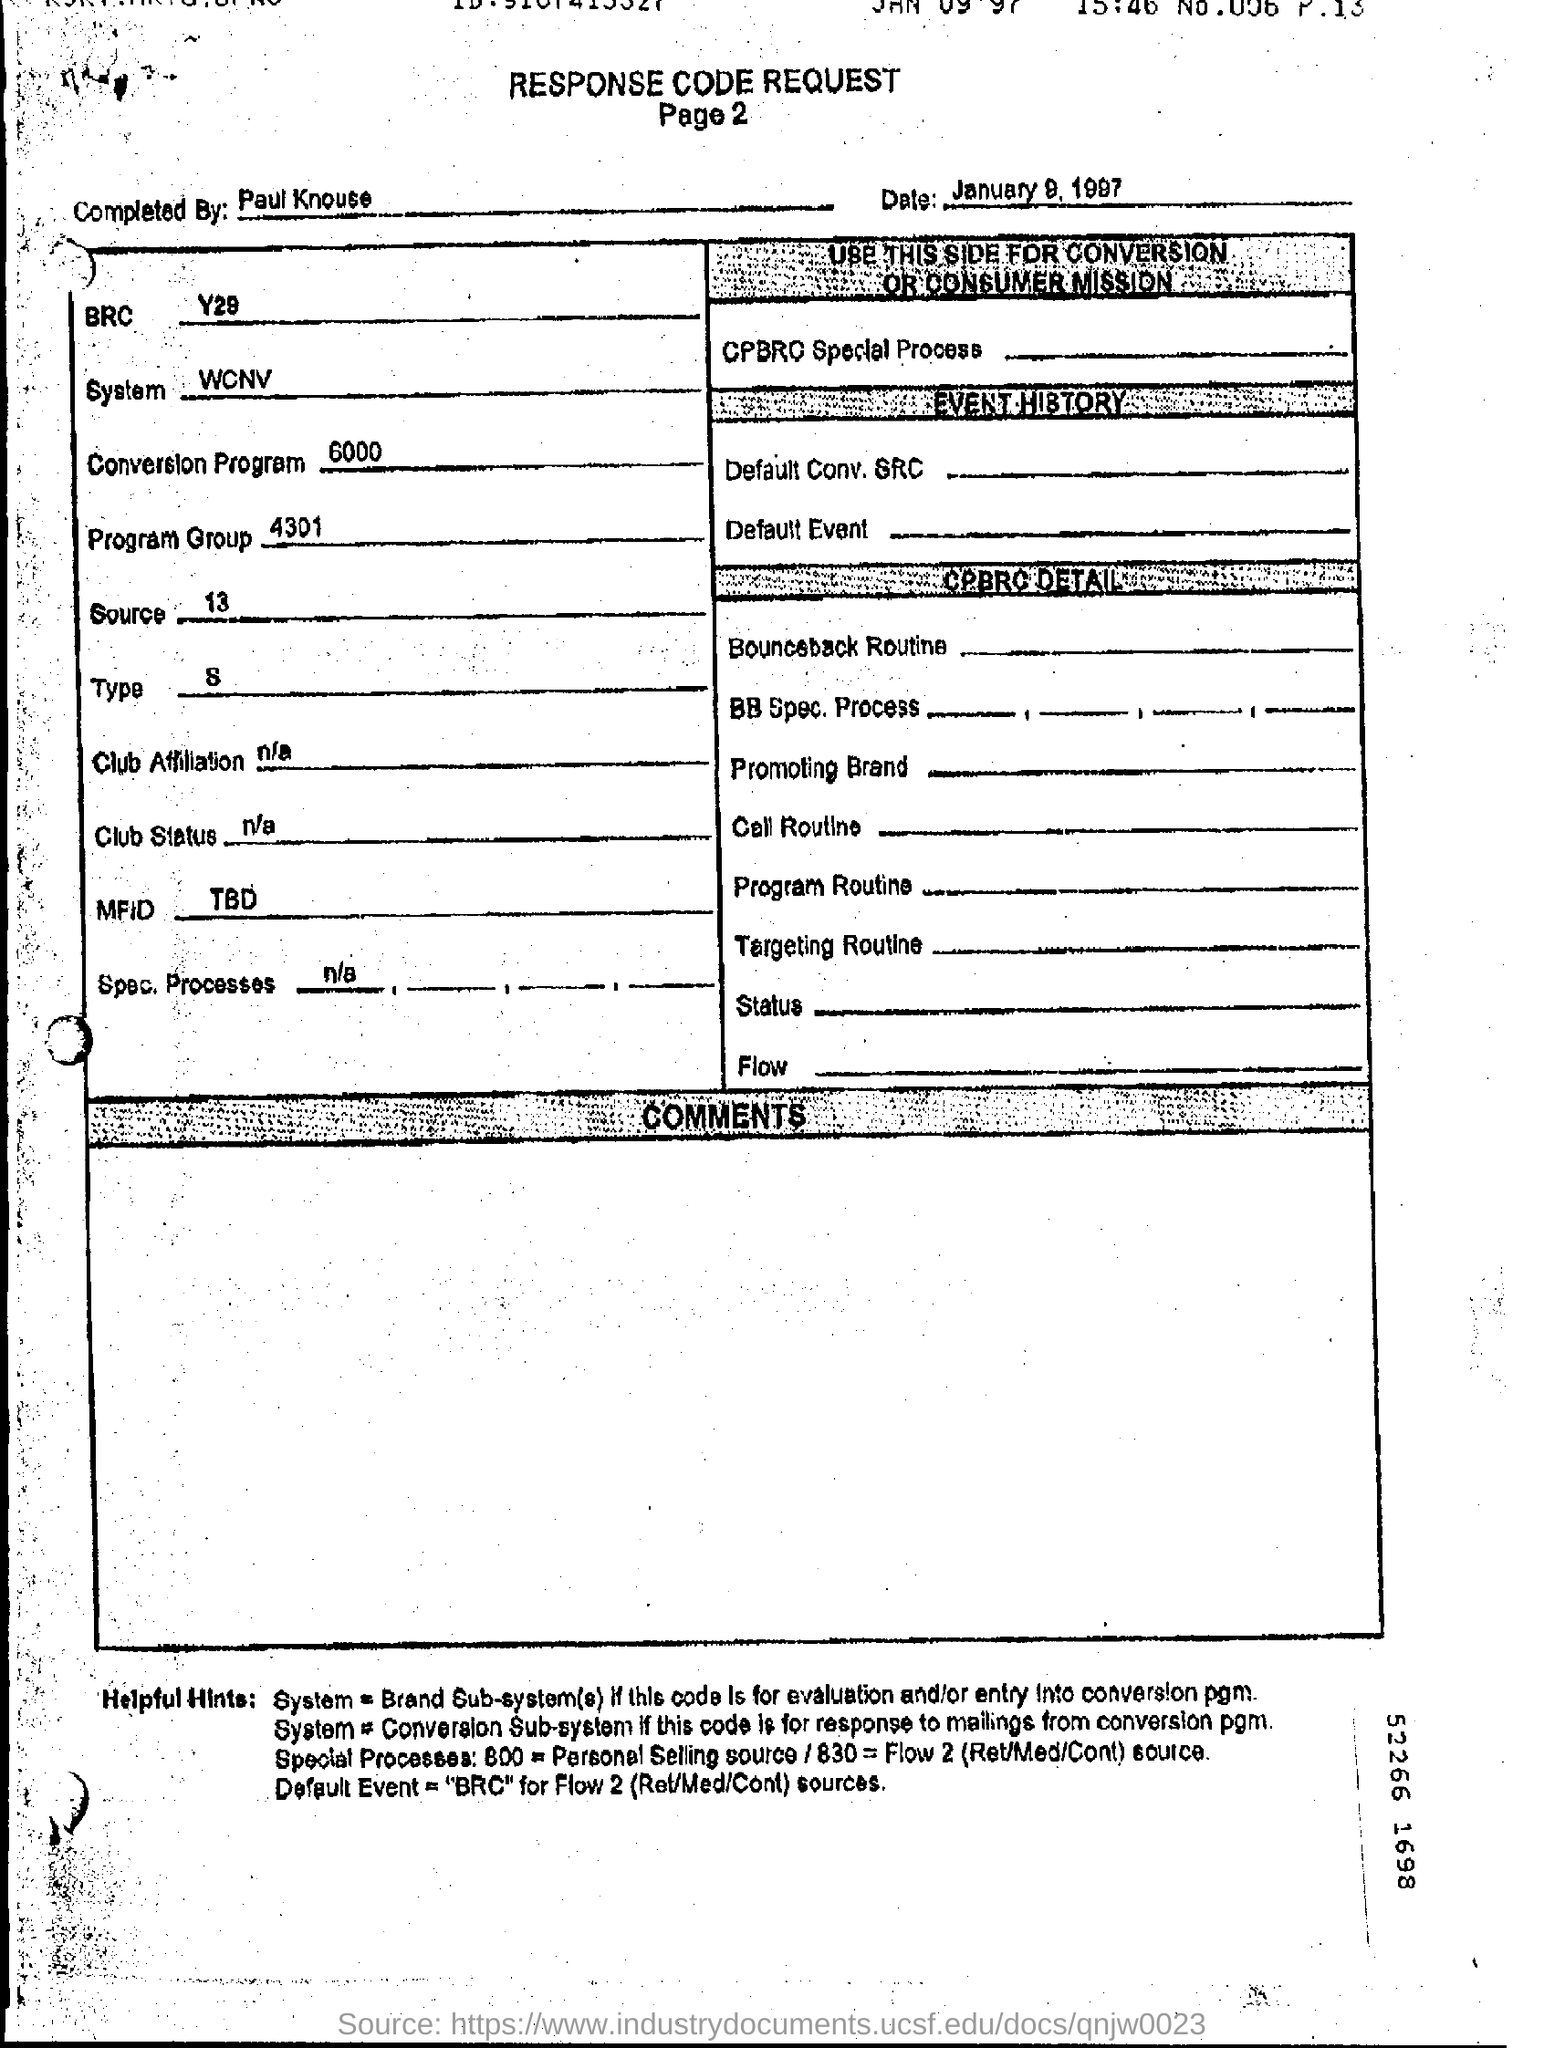What is the date mentioned?
Your answer should be very brief. January 9, 1997. 